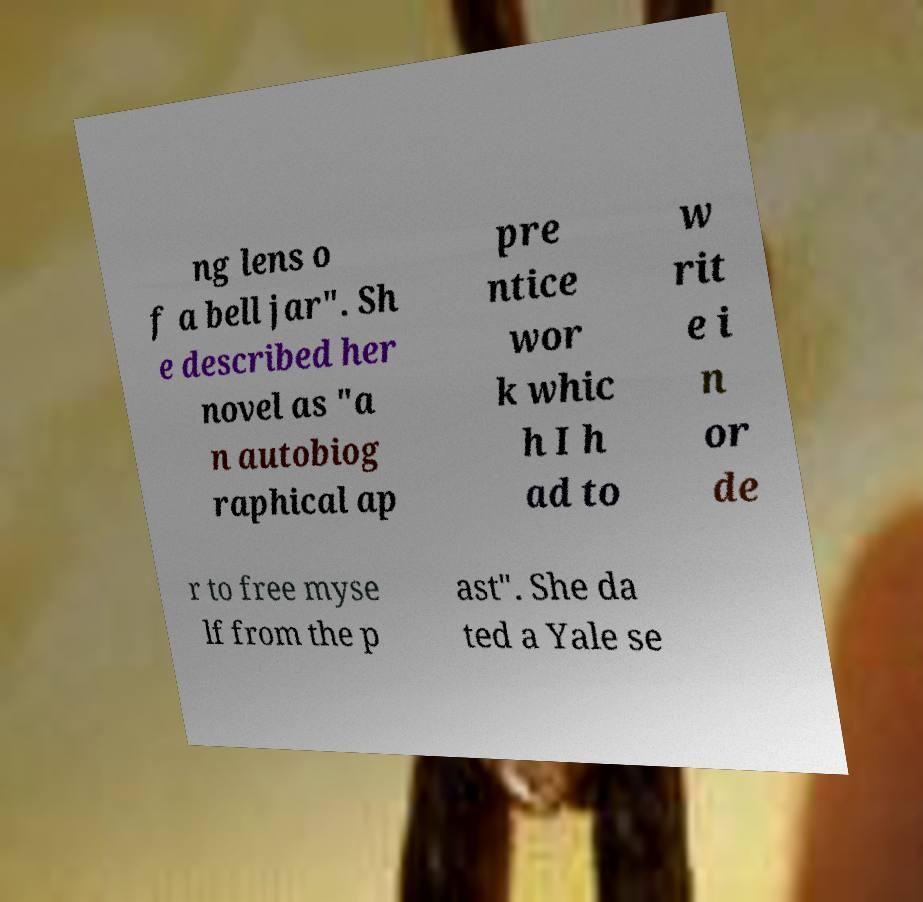Could you assist in decoding the text presented in this image and type it out clearly? ng lens o f a bell jar". Sh e described her novel as "a n autobiog raphical ap pre ntice wor k whic h I h ad to w rit e i n or de r to free myse lf from the p ast". She da ted a Yale se 